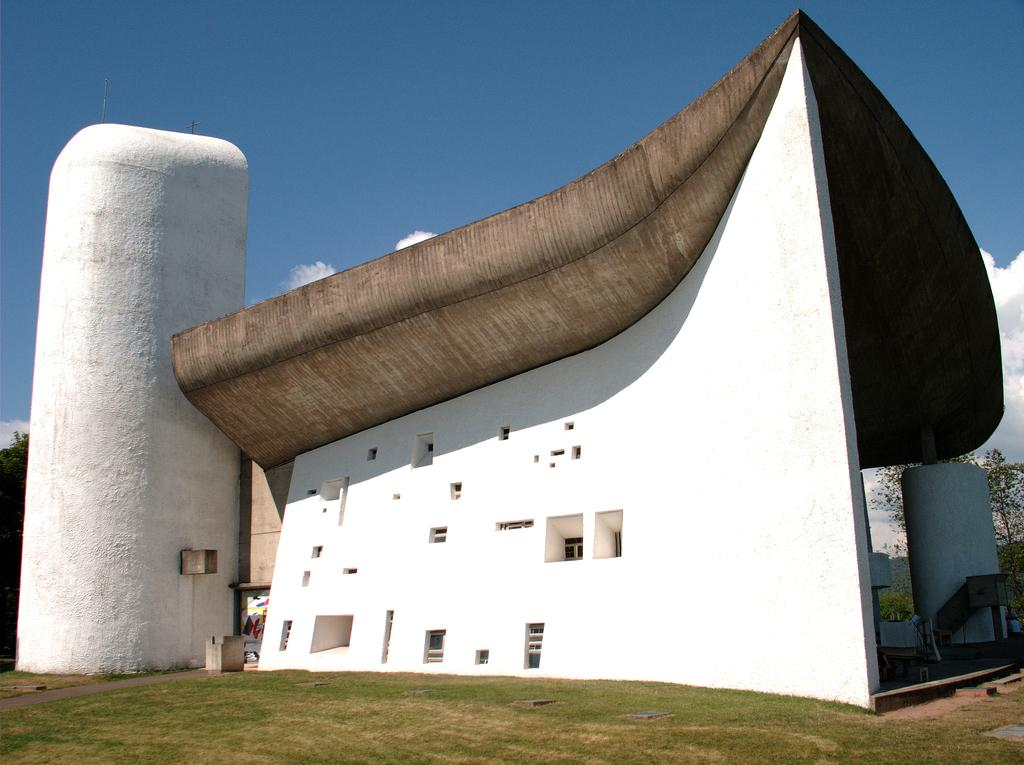What type of vegetation can be seen in the image? There is grass in the image. What type of structure is present in the image? There is a building in the image. What other natural elements can be seen in the image? There are trees in the image. What is visible in the background of the image? The sky is visible in the background of the image. What can be observed in the sky? Clouds are present in the sky. How many babies are playing with wool in the image? There are no babies or wool present in the image. What type of driving is taking place in the image? There is no driving present in the image. 